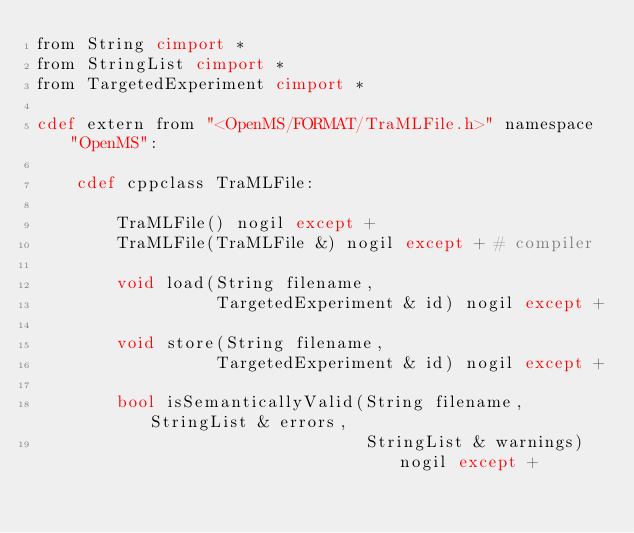<code> <loc_0><loc_0><loc_500><loc_500><_Cython_>from String cimport *
from StringList cimport *
from TargetedExperiment cimport *

cdef extern from "<OpenMS/FORMAT/TraMLFile.h>" namespace "OpenMS":

    cdef cppclass TraMLFile:

        TraMLFile() nogil except +
        TraMLFile(TraMLFile &) nogil except + # compiler

        void load(String filename,
                  TargetedExperiment & id) nogil except +

        void store(String filename,
                  TargetedExperiment & id) nogil except +

        bool isSemanticallyValid(String filename, StringList & errors,
                                 StringList & warnings) nogil except +
</code> 